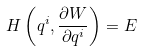<formula> <loc_0><loc_0><loc_500><loc_500>H \left ( q ^ { i } , \frac { \partial W } { \partial q ^ { i } } \right ) = E</formula> 